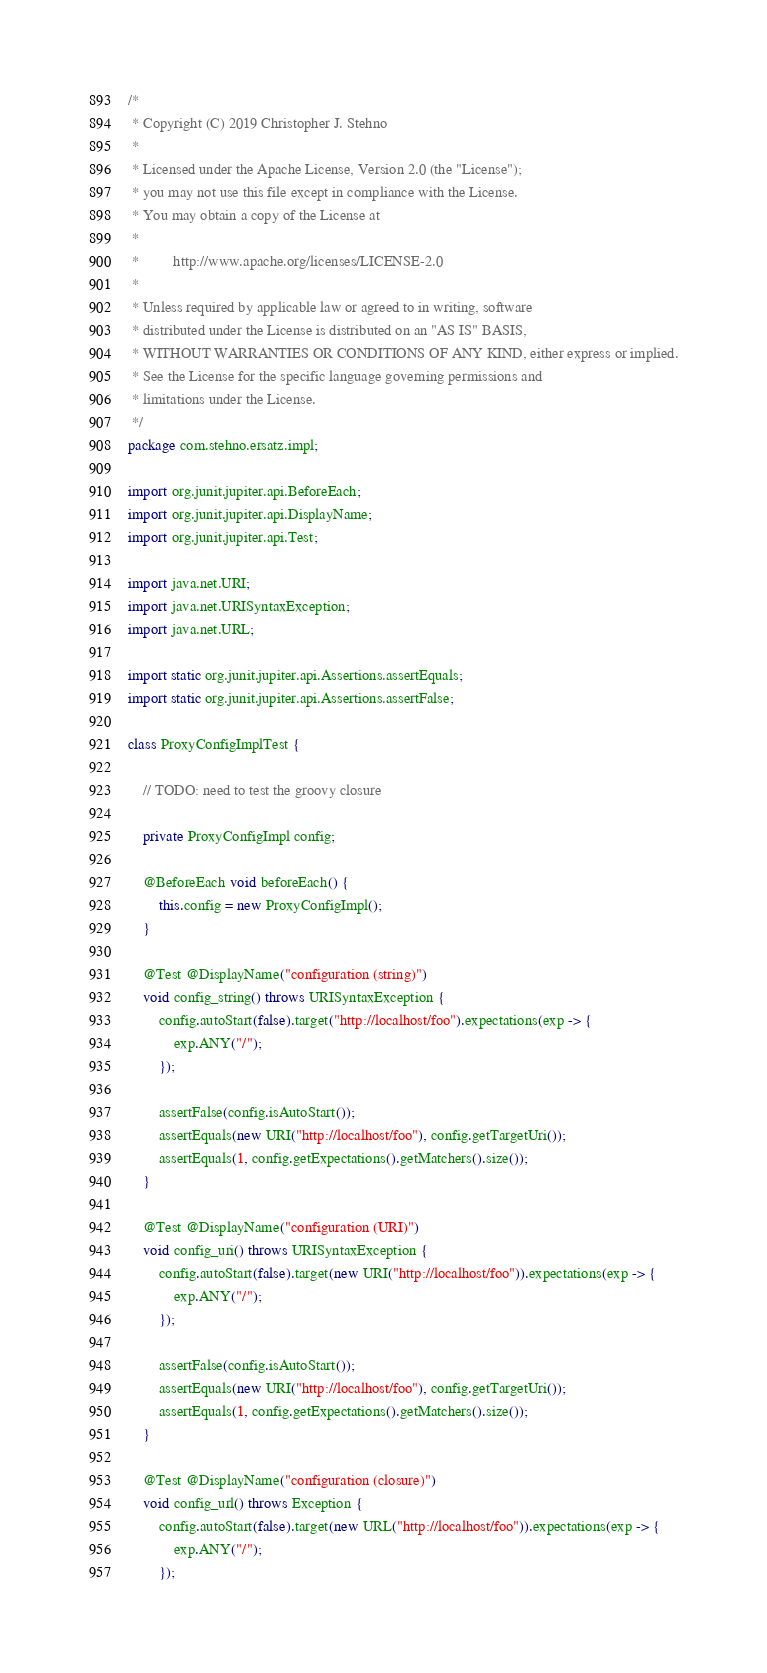Convert code to text. <code><loc_0><loc_0><loc_500><loc_500><_Java_>/*
 * Copyright (C) 2019 Christopher J. Stehno
 *
 * Licensed under the Apache License, Version 2.0 (the "License");
 * you may not use this file except in compliance with the License.
 * You may obtain a copy of the License at
 *
 *         http://www.apache.org/licenses/LICENSE-2.0
 *
 * Unless required by applicable law or agreed to in writing, software
 * distributed under the License is distributed on an "AS IS" BASIS,
 * WITHOUT WARRANTIES OR CONDITIONS OF ANY KIND, either express or implied.
 * See the License for the specific language governing permissions and
 * limitations under the License.
 */
package com.stehno.ersatz.impl;

import org.junit.jupiter.api.BeforeEach;
import org.junit.jupiter.api.DisplayName;
import org.junit.jupiter.api.Test;

import java.net.URI;
import java.net.URISyntaxException;
import java.net.URL;

import static org.junit.jupiter.api.Assertions.assertEquals;
import static org.junit.jupiter.api.Assertions.assertFalse;

class ProxyConfigImplTest {

    // TODO: need to test the groovy closure

    private ProxyConfigImpl config;

    @BeforeEach void beforeEach() {
        this.config = new ProxyConfigImpl();
    }

    @Test @DisplayName("configuration (string)")
    void config_string() throws URISyntaxException {
        config.autoStart(false).target("http://localhost/foo").expectations(exp -> {
            exp.ANY("/");
        });

        assertFalse(config.isAutoStart());
        assertEquals(new URI("http://localhost/foo"), config.getTargetUri());
        assertEquals(1, config.getExpectations().getMatchers().size());
    }

    @Test @DisplayName("configuration (URI)")
    void config_uri() throws URISyntaxException {
        config.autoStart(false).target(new URI("http://localhost/foo")).expectations(exp -> {
            exp.ANY("/");
        });

        assertFalse(config.isAutoStart());
        assertEquals(new URI("http://localhost/foo"), config.getTargetUri());
        assertEquals(1, config.getExpectations().getMatchers().size());
    }

    @Test @DisplayName("configuration (closure)")
    void config_url() throws Exception {
        config.autoStart(false).target(new URL("http://localhost/foo")).expectations(exp -> {
            exp.ANY("/");
        });
</code> 